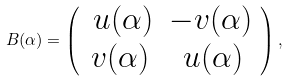<formula> <loc_0><loc_0><loc_500><loc_500>B ( \alpha ) = \left ( \begin{array} { c c } \, u ( \alpha ) & - v ( \alpha ) \\ v ( \alpha ) & \, u ( \alpha ) \end{array} \right ) ,</formula> 